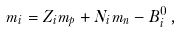Convert formula to latex. <formula><loc_0><loc_0><loc_500><loc_500>m _ { i } = Z _ { i } m _ { p } + N _ { i } m _ { n } - B _ { i } ^ { 0 } \, ,</formula> 